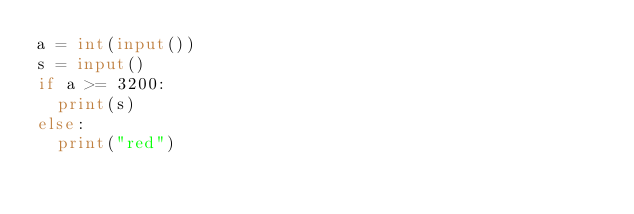<code> <loc_0><loc_0><loc_500><loc_500><_Python_>a = int(input())
s = input()
if a >= 3200:
	print(s)
else:
	print("red")</code> 